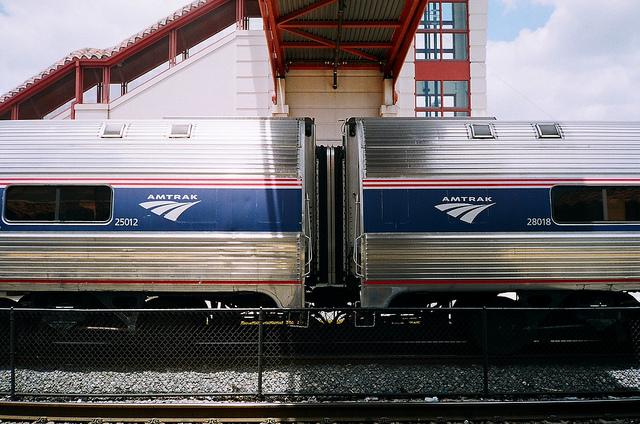Who owns this train?
Quick response, please. Amtrak. What is the number on the train?
Quick response, please. 25012. Does it look like it is going to rain?
Answer briefly. No. 